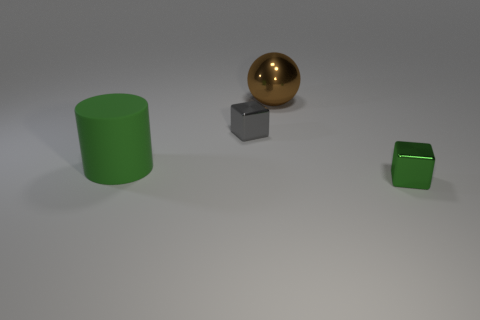Is there any other thing that has the same color as the matte thing?
Provide a succinct answer. Yes. Do the tiny thing behind the big green cylinder and the cylinder have the same material?
Offer a terse response. No. Are there more green metallic things in front of the small gray thing than tiny green cubes on the left side of the matte cylinder?
Make the answer very short. Yes. There is a metal cube that is the same size as the gray thing; what is its color?
Keep it short and to the point. Green. Is there a tiny shiny object of the same color as the big cylinder?
Your answer should be compact. Yes. There is a small cube in front of the big green matte object; does it have the same color as the thing left of the gray metal cube?
Provide a succinct answer. Yes. What is the material of the green object behind the green shiny cube?
Give a very brief answer. Rubber. There is a tiny object that is made of the same material as the small gray block; what is its color?
Provide a short and direct response. Green. What number of metal balls have the same size as the gray thing?
Your answer should be compact. 0. Do the cube behind the green shiny block and the green block have the same size?
Keep it short and to the point. Yes. 